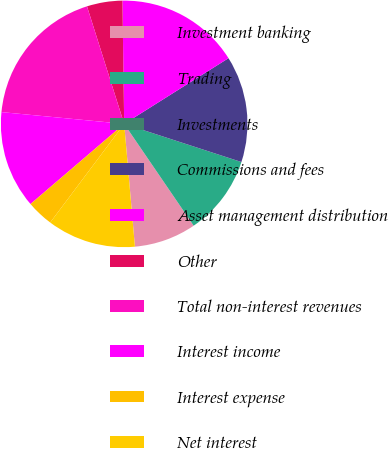Convert chart to OTSL. <chart><loc_0><loc_0><loc_500><loc_500><pie_chart><fcel>Investment banking<fcel>Trading<fcel>Investments<fcel>Commissions and fees<fcel>Asset management distribution<fcel>Other<fcel>Total non-interest revenues<fcel>Interest income<fcel>Interest expense<fcel>Net interest<nl><fcel>8.14%<fcel>10.46%<fcel>0.0%<fcel>13.95%<fcel>16.28%<fcel>4.65%<fcel>18.6%<fcel>12.79%<fcel>3.49%<fcel>11.63%<nl></chart> 